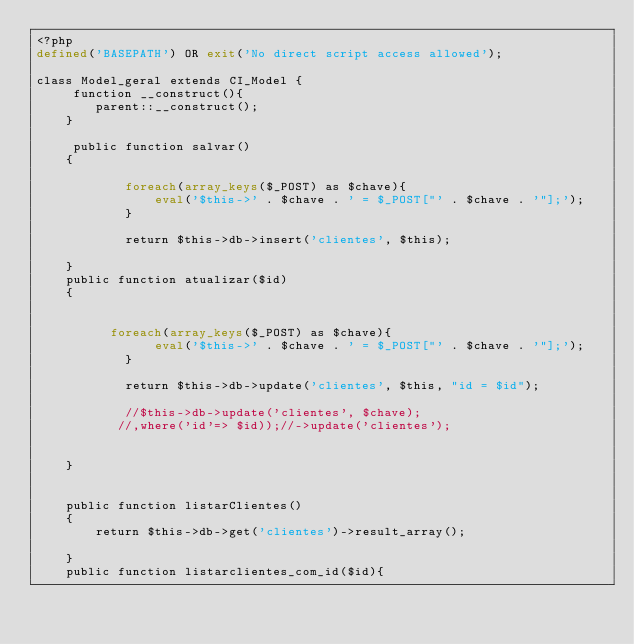Convert code to text. <code><loc_0><loc_0><loc_500><loc_500><_PHP_><?php
defined('BASEPATH') OR exit('No direct script access allowed');

class Model_geral extends CI_Model {
     function __construct(){
        parent::__construct();
    }
    
     public function salvar()
    {
 
            foreach(array_keys($_POST) as $chave){
                eval('$this->' . $chave . ' = $_POST["' . $chave . '"];');
            }
            
            return $this->db->insert('clientes', $this);

    }
    public function atualizar($id)
    {

            
          foreach(array_keys($_POST) as $chave){
                eval('$this->' . $chave . ' = $_POST["' . $chave . '"];');
            }

            return $this->db->update('clientes', $this, "id = $id");
 
            //$this->db->update('clientes', $chave);
           //,where('id'=> $id));//->update('clientes');
           

    }
    
   
    public function listarClientes()
    {
        return $this->db->get('clientes')->result_array();
	  
    }
    public function listarclientes_com_id($id){</code> 